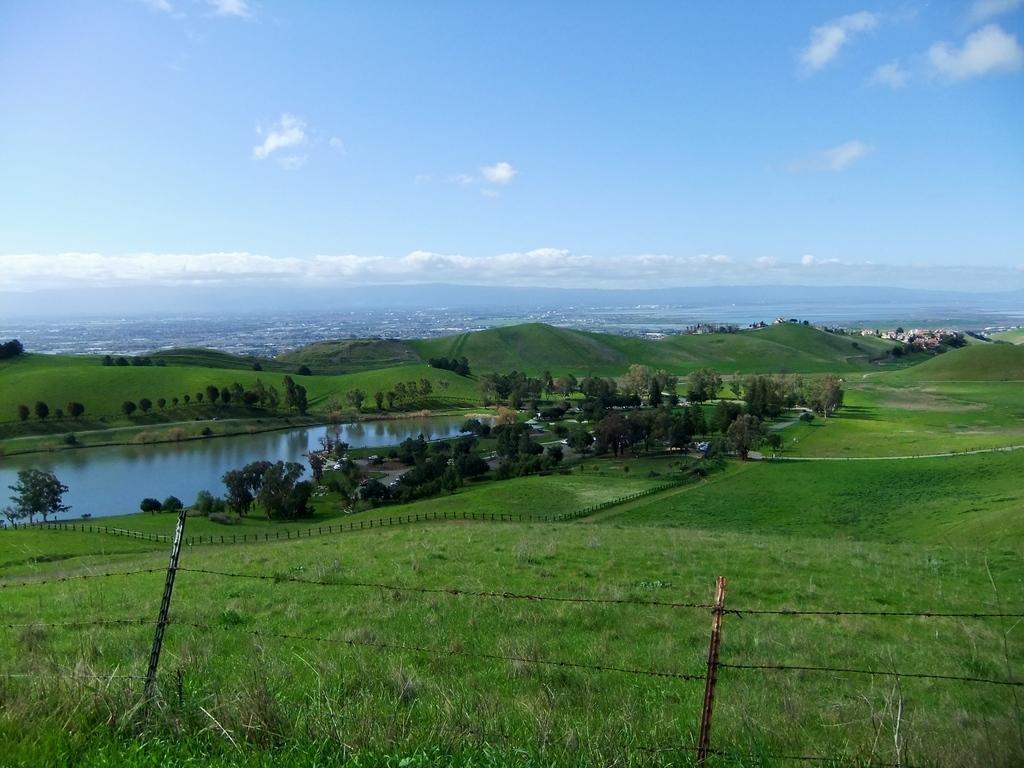Can you describe this image briefly? In the foreground of the picture there are crops, fencing and shrubs. In the middle of the picture there are trees, fields and water body. In the background we can see aerial view of a town or city. At the top there is sky. 